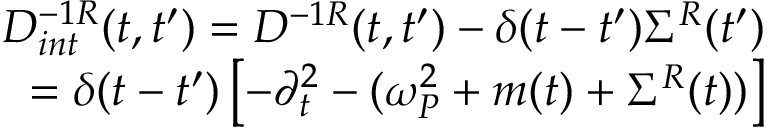Convert formula to latex. <formula><loc_0><loc_0><loc_500><loc_500>\begin{array} { r l r } & { D _ { i n t } ^ { - 1 R } ( t , t ^ { \prime } ) = D ^ { - 1 R } ( t , t ^ { \prime } ) - \delta ( t - t ^ { \prime } ) \Sigma ^ { R } ( t ^ { \prime } ) } \\ & { = \delta ( t - t ^ { \prime } ) \left [ - \partial _ { t } ^ { 2 } - ( \omega _ { P } ^ { 2 } + m ( t ) + \Sigma ^ { R } ( t ) ) \right ] } \end{array}</formula> 